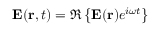<formula> <loc_0><loc_0><loc_500><loc_500>E ( r , t ) = \Re \left \{ E ( r ) e ^ { i \omega t } \right \}</formula> 